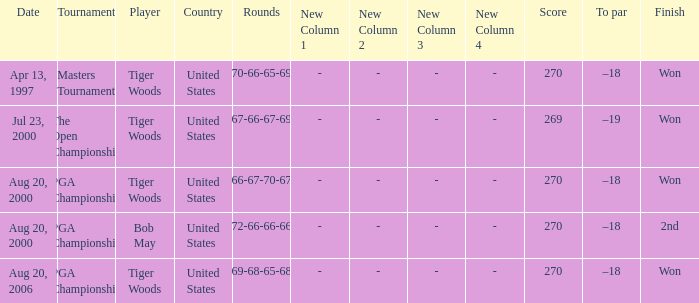What players finished 2nd? Bob May. 